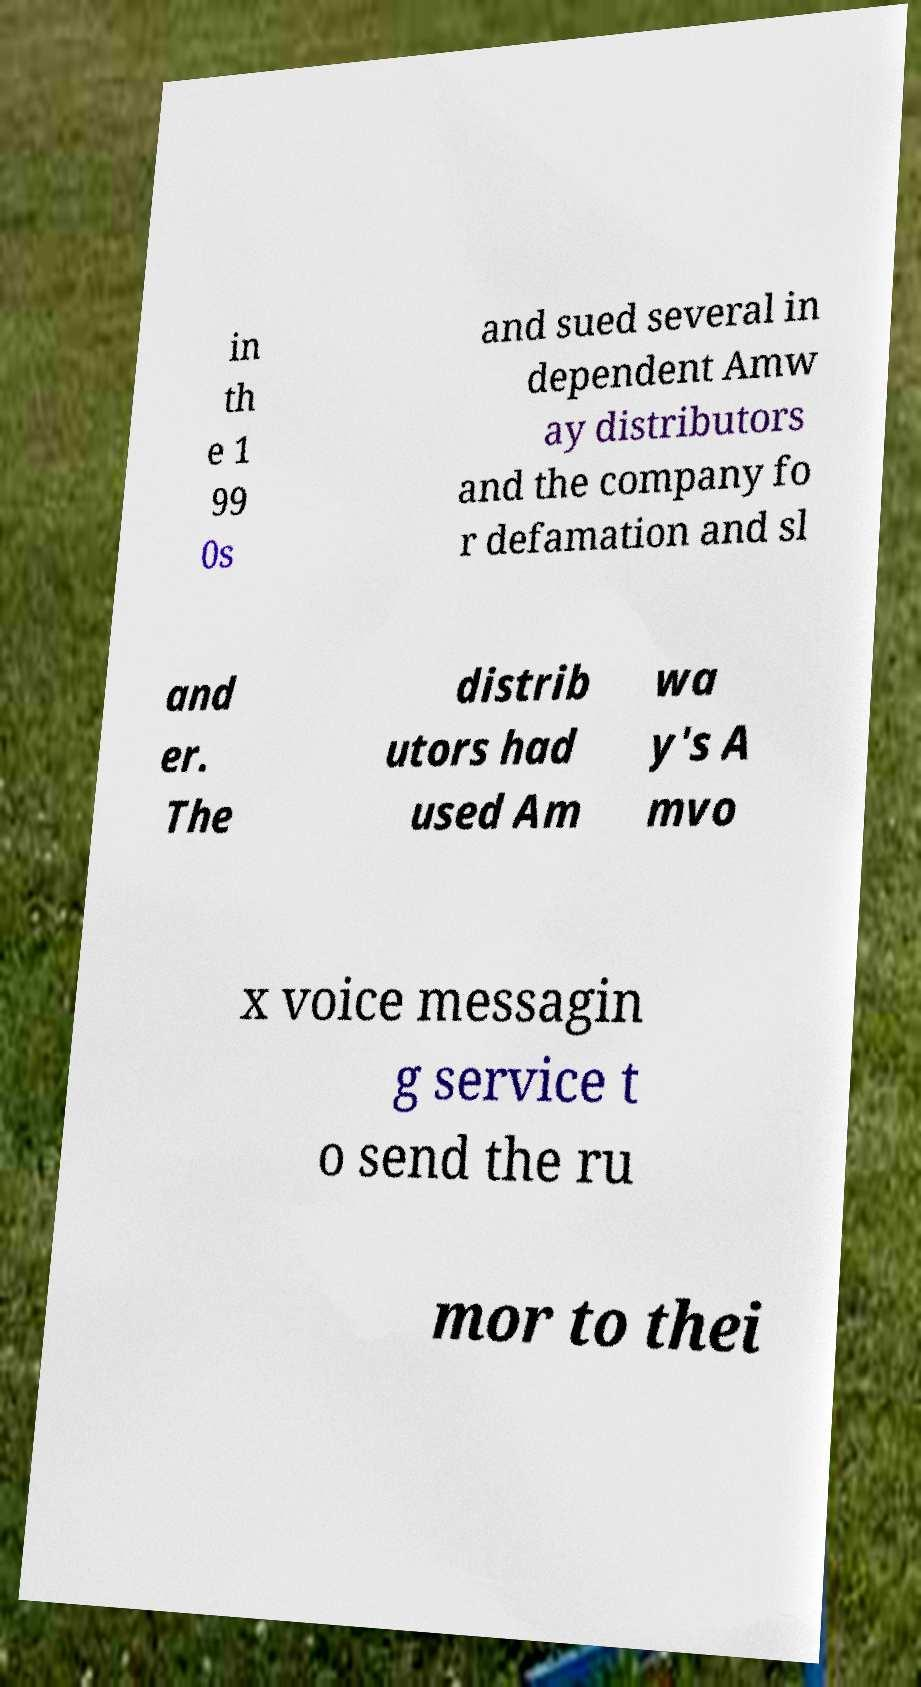Can you read and provide the text displayed in the image?This photo seems to have some interesting text. Can you extract and type it out for me? in th e 1 99 0s and sued several in dependent Amw ay distributors and the company fo r defamation and sl and er. The distrib utors had used Am wa y's A mvo x voice messagin g service t o send the ru mor to thei 